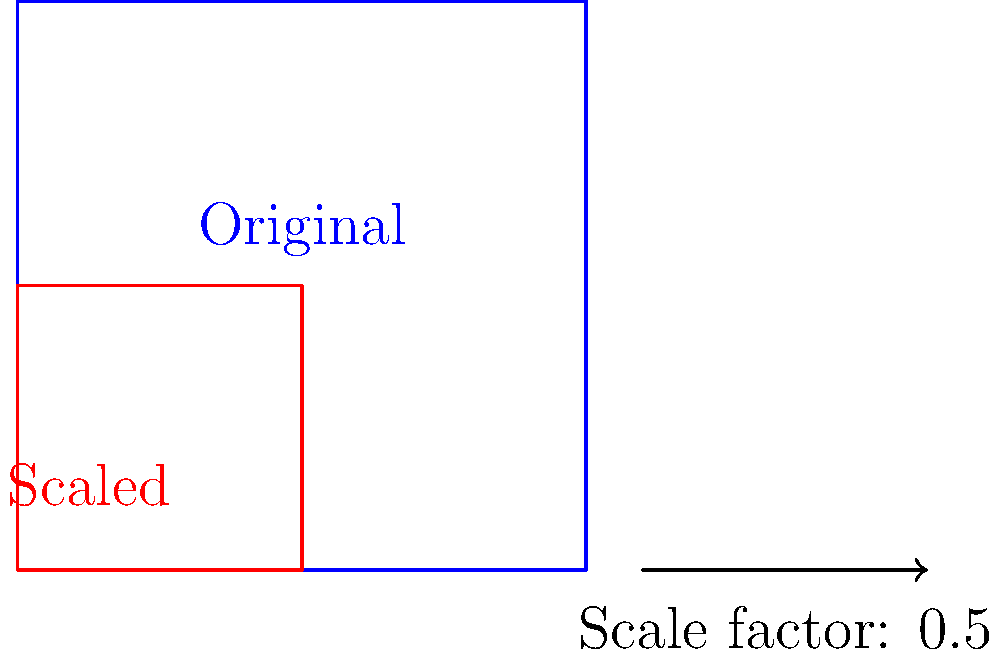You're designing a t-shirt featuring an iconic movie symbol, but need to scale it down to fit the garment. If the original symbol measures 8 inches in width and you apply a scale factor of 0.5, what will be the new width of the symbol on your design? To solve this problem, we'll follow these steps:

1. Understand the given information:
   - Original width of the symbol: 8 inches
   - Scale factor: 0.5

2. Recall the formula for scaling:
   New dimension = Original dimension × Scale factor

3. Apply the formula:
   New width = 8 inches × 0.5

4. Perform the calculation:
   New width = 4 inches

The scale factor of 0.5 means we're reducing the size by half. This is why the new width is exactly half of the original width.

In the diagram, we can see how the red square (scaled symbol) is half the size of the blue square (original symbol) in both width and height, visually representing this scaling process.
Answer: 4 inches 